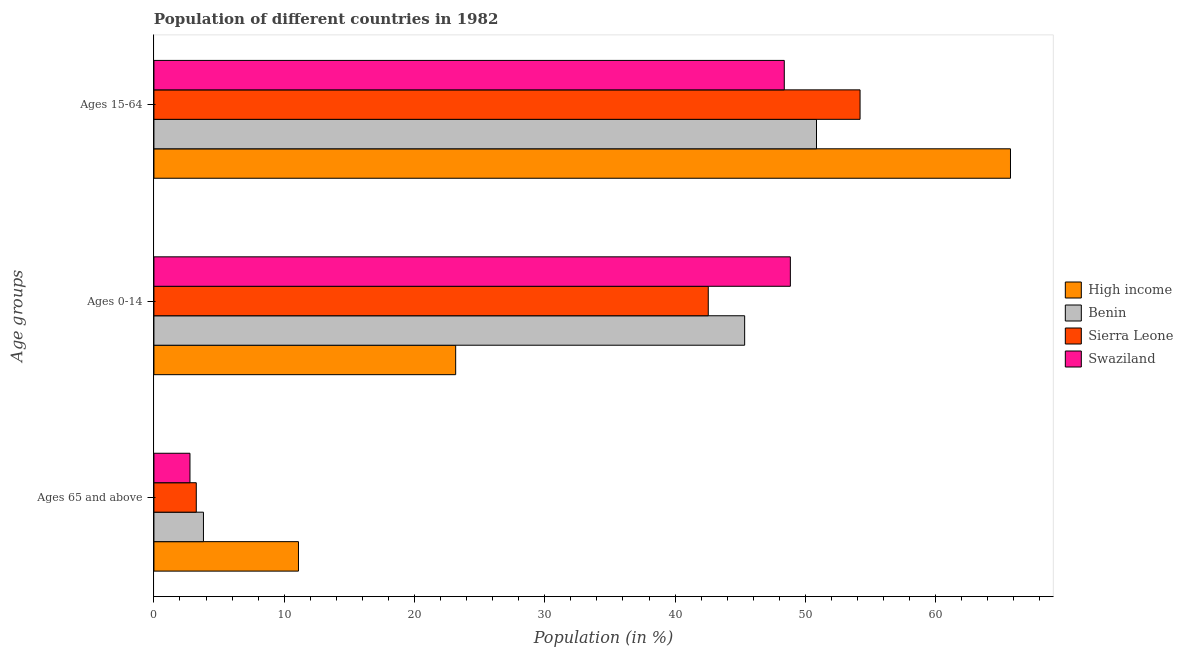How many different coloured bars are there?
Make the answer very short. 4. How many groups of bars are there?
Your answer should be compact. 3. What is the label of the 3rd group of bars from the top?
Your response must be concise. Ages 65 and above. What is the percentage of population within the age-group of 65 and above in Sierra Leone?
Provide a succinct answer. 3.25. Across all countries, what is the maximum percentage of population within the age-group 15-64?
Your answer should be compact. 65.75. Across all countries, what is the minimum percentage of population within the age-group 15-64?
Provide a short and direct response. 48.38. In which country was the percentage of population within the age-group 15-64 minimum?
Keep it short and to the point. Swaziland. What is the total percentage of population within the age-group 15-64 in the graph?
Provide a succinct answer. 219.19. What is the difference between the percentage of population within the age-group 0-14 in Benin and that in High income?
Make the answer very short. 22.18. What is the difference between the percentage of population within the age-group 15-64 in Sierra Leone and the percentage of population within the age-group 0-14 in High income?
Offer a terse response. 31.04. What is the average percentage of population within the age-group 0-14 per country?
Make the answer very short. 39.98. What is the difference between the percentage of population within the age-group of 65 and above and percentage of population within the age-group 15-64 in Swaziland?
Offer a very short reply. -45.62. In how many countries, is the percentage of population within the age-group of 65 and above greater than 62 %?
Provide a short and direct response. 0. What is the ratio of the percentage of population within the age-group 15-64 in Swaziland to that in Benin?
Keep it short and to the point. 0.95. Is the percentage of population within the age-group 0-14 in High income less than that in Sierra Leone?
Provide a succinct answer. Yes. Is the difference between the percentage of population within the age-group 15-64 in Swaziland and High income greater than the difference between the percentage of population within the age-group of 65 and above in Swaziland and High income?
Provide a succinct answer. No. What is the difference between the highest and the second highest percentage of population within the age-group 0-14?
Keep it short and to the point. 3.51. What is the difference between the highest and the lowest percentage of population within the age-group of 65 and above?
Ensure brevity in your answer.  8.33. Is the sum of the percentage of population within the age-group of 65 and above in Swaziland and Benin greater than the maximum percentage of population within the age-group 0-14 across all countries?
Your response must be concise. No. What does the 3rd bar from the bottom in Ages 15-64 represents?
Your answer should be compact. Sierra Leone. How many bars are there?
Provide a short and direct response. 12. Are all the bars in the graph horizontal?
Your response must be concise. Yes. What is the difference between two consecutive major ticks on the X-axis?
Your answer should be very brief. 10. Are the values on the major ticks of X-axis written in scientific E-notation?
Offer a terse response. No. Where does the legend appear in the graph?
Ensure brevity in your answer.  Center right. How many legend labels are there?
Offer a very short reply. 4. What is the title of the graph?
Provide a succinct answer. Population of different countries in 1982. What is the label or title of the X-axis?
Ensure brevity in your answer.  Population (in %). What is the label or title of the Y-axis?
Offer a very short reply. Age groups. What is the Population (in %) of High income in Ages 65 and above?
Your answer should be very brief. 11.09. What is the Population (in %) in Benin in Ages 65 and above?
Make the answer very short. 3.8. What is the Population (in %) of Sierra Leone in Ages 65 and above?
Give a very brief answer. 3.25. What is the Population (in %) of Swaziland in Ages 65 and above?
Offer a very short reply. 2.77. What is the Population (in %) in High income in Ages 0-14?
Offer a terse response. 23.16. What is the Population (in %) of Benin in Ages 0-14?
Provide a succinct answer. 45.34. What is the Population (in %) in Sierra Leone in Ages 0-14?
Make the answer very short. 42.55. What is the Population (in %) in Swaziland in Ages 0-14?
Ensure brevity in your answer.  48.85. What is the Population (in %) in High income in Ages 15-64?
Your answer should be very brief. 65.75. What is the Population (in %) of Benin in Ages 15-64?
Make the answer very short. 50.86. What is the Population (in %) in Sierra Leone in Ages 15-64?
Your response must be concise. 54.2. What is the Population (in %) of Swaziland in Ages 15-64?
Offer a very short reply. 48.38. Across all Age groups, what is the maximum Population (in %) of High income?
Keep it short and to the point. 65.75. Across all Age groups, what is the maximum Population (in %) of Benin?
Keep it short and to the point. 50.86. Across all Age groups, what is the maximum Population (in %) of Sierra Leone?
Offer a very short reply. 54.2. Across all Age groups, what is the maximum Population (in %) of Swaziland?
Your response must be concise. 48.85. Across all Age groups, what is the minimum Population (in %) of High income?
Keep it short and to the point. 11.09. Across all Age groups, what is the minimum Population (in %) of Benin?
Make the answer very short. 3.8. Across all Age groups, what is the minimum Population (in %) in Sierra Leone?
Provide a short and direct response. 3.25. Across all Age groups, what is the minimum Population (in %) of Swaziland?
Your answer should be very brief. 2.77. What is the total Population (in %) of Benin in the graph?
Make the answer very short. 100. What is the difference between the Population (in %) of High income in Ages 65 and above and that in Ages 0-14?
Make the answer very short. -12.07. What is the difference between the Population (in %) in Benin in Ages 65 and above and that in Ages 0-14?
Offer a terse response. -41.54. What is the difference between the Population (in %) in Sierra Leone in Ages 65 and above and that in Ages 0-14?
Ensure brevity in your answer.  -39.3. What is the difference between the Population (in %) in Swaziland in Ages 65 and above and that in Ages 0-14?
Your answer should be very brief. -46.08. What is the difference between the Population (in %) of High income in Ages 65 and above and that in Ages 15-64?
Your response must be concise. -54.65. What is the difference between the Population (in %) of Benin in Ages 65 and above and that in Ages 15-64?
Your answer should be very brief. -47.06. What is the difference between the Population (in %) in Sierra Leone in Ages 65 and above and that in Ages 15-64?
Provide a short and direct response. -50.95. What is the difference between the Population (in %) in Swaziland in Ages 65 and above and that in Ages 15-64?
Offer a very short reply. -45.62. What is the difference between the Population (in %) in High income in Ages 0-14 and that in Ages 15-64?
Keep it short and to the point. -42.59. What is the difference between the Population (in %) in Benin in Ages 0-14 and that in Ages 15-64?
Offer a terse response. -5.51. What is the difference between the Population (in %) of Sierra Leone in Ages 0-14 and that in Ages 15-64?
Your response must be concise. -11.65. What is the difference between the Population (in %) in Swaziland in Ages 0-14 and that in Ages 15-64?
Offer a terse response. 0.47. What is the difference between the Population (in %) of High income in Ages 65 and above and the Population (in %) of Benin in Ages 0-14?
Offer a very short reply. -34.25. What is the difference between the Population (in %) of High income in Ages 65 and above and the Population (in %) of Sierra Leone in Ages 0-14?
Offer a terse response. -31.45. What is the difference between the Population (in %) in High income in Ages 65 and above and the Population (in %) in Swaziland in Ages 0-14?
Make the answer very short. -37.76. What is the difference between the Population (in %) of Benin in Ages 65 and above and the Population (in %) of Sierra Leone in Ages 0-14?
Your answer should be compact. -38.75. What is the difference between the Population (in %) in Benin in Ages 65 and above and the Population (in %) in Swaziland in Ages 0-14?
Offer a terse response. -45.05. What is the difference between the Population (in %) of Sierra Leone in Ages 65 and above and the Population (in %) of Swaziland in Ages 0-14?
Make the answer very short. -45.6. What is the difference between the Population (in %) in High income in Ages 65 and above and the Population (in %) in Benin in Ages 15-64?
Provide a short and direct response. -39.76. What is the difference between the Population (in %) in High income in Ages 65 and above and the Population (in %) in Sierra Leone in Ages 15-64?
Your answer should be compact. -43.11. What is the difference between the Population (in %) in High income in Ages 65 and above and the Population (in %) in Swaziland in Ages 15-64?
Your answer should be very brief. -37.29. What is the difference between the Population (in %) in Benin in Ages 65 and above and the Population (in %) in Sierra Leone in Ages 15-64?
Your answer should be compact. -50.4. What is the difference between the Population (in %) of Benin in Ages 65 and above and the Population (in %) of Swaziland in Ages 15-64?
Your response must be concise. -44.58. What is the difference between the Population (in %) in Sierra Leone in Ages 65 and above and the Population (in %) in Swaziland in Ages 15-64?
Your answer should be very brief. -45.13. What is the difference between the Population (in %) in High income in Ages 0-14 and the Population (in %) in Benin in Ages 15-64?
Your response must be concise. -27.7. What is the difference between the Population (in %) in High income in Ages 0-14 and the Population (in %) in Sierra Leone in Ages 15-64?
Offer a terse response. -31.04. What is the difference between the Population (in %) of High income in Ages 0-14 and the Population (in %) of Swaziland in Ages 15-64?
Provide a short and direct response. -25.22. What is the difference between the Population (in %) of Benin in Ages 0-14 and the Population (in %) of Sierra Leone in Ages 15-64?
Make the answer very short. -8.86. What is the difference between the Population (in %) of Benin in Ages 0-14 and the Population (in %) of Swaziland in Ages 15-64?
Provide a succinct answer. -3.04. What is the difference between the Population (in %) of Sierra Leone in Ages 0-14 and the Population (in %) of Swaziland in Ages 15-64?
Provide a short and direct response. -5.83. What is the average Population (in %) of High income per Age groups?
Make the answer very short. 33.33. What is the average Population (in %) in Benin per Age groups?
Provide a short and direct response. 33.33. What is the average Population (in %) in Sierra Leone per Age groups?
Keep it short and to the point. 33.33. What is the average Population (in %) of Swaziland per Age groups?
Ensure brevity in your answer.  33.33. What is the difference between the Population (in %) in High income and Population (in %) in Benin in Ages 65 and above?
Your answer should be compact. 7.29. What is the difference between the Population (in %) of High income and Population (in %) of Sierra Leone in Ages 65 and above?
Provide a succinct answer. 7.84. What is the difference between the Population (in %) of High income and Population (in %) of Swaziland in Ages 65 and above?
Provide a short and direct response. 8.33. What is the difference between the Population (in %) in Benin and Population (in %) in Sierra Leone in Ages 65 and above?
Ensure brevity in your answer.  0.55. What is the difference between the Population (in %) of Benin and Population (in %) of Swaziland in Ages 65 and above?
Offer a terse response. 1.03. What is the difference between the Population (in %) in Sierra Leone and Population (in %) in Swaziland in Ages 65 and above?
Provide a short and direct response. 0.48. What is the difference between the Population (in %) in High income and Population (in %) in Benin in Ages 0-14?
Your response must be concise. -22.18. What is the difference between the Population (in %) of High income and Population (in %) of Sierra Leone in Ages 0-14?
Your response must be concise. -19.39. What is the difference between the Population (in %) of High income and Population (in %) of Swaziland in Ages 0-14?
Your response must be concise. -25.69. What is the difference between the Population (in %) of Benin and Population (in %) of Sierra Leone in Ages 0-14?
Offer a very short reply. 2.79. What is the difference between the Population (in %) in Benin and Population (in %) in Swaziland in Ages 0-14?
Give a very brief answer. -3.51. What is the difference between the Population (in %) of Sierra Leone and Population (in %) of Swaziland in Ages 0-14?
Make the answer very short. -6.3. What is the difference between the Population (in %) in High income and Population (in %) in Benin in Ages 15-64?
Provide a short and direct response. 14.89. What is the difference between the Population (in %) in High income and Population (in %) in Sierra Leone in Ages 15-64?
Offer a very short reply. 11.55. What is the difference between the Population (in %) of High income and Population (in %) of Swaziland in Ages 15-64?
Your response must be concise. 17.36. What is the difference between the Population (in %) of Benin and Population (in %) of Sierra Leone in Ages 15-64?
Make the answer very short. -3.34. What is the difference between the Population (in %) in Benin and Population (in %) in Swaziland in Ages 15-64?
Provide a succinct answer. 2.47. What is the difference between the Population (in %) of Sierra Leone and Population (in %) of Swaziland in Ages 15-64?
Ensure brevity in your answer.  5.82. What is the ratio of the Population (in %) of High income in Ages 65 and above to that in Ages 0-14?
Your answer should be very brief. 0.48. What is the ratio of the Population (in %) of Benin in Ages 65 and above to that in Ages 0-14?
Provide a succinct answer. 0.08. What is the ratio of the Population (in %) in Sierra Leone in Ages 65 and above to that in Ages 0-14?
Ensure brevity in your answer.  0.08. What is the ratio of the Population (in %) of Swaziland in Ages 65 and above to that in Ages 0-14?
Give a very brief answer. 0.06. What is the ratio of the Population (in %) of High income in Ages 65 and above to that in Ages 15-64?
Make the answer very short. 0.17. What is the ratio of the Population (in %) in Benin in Ages 65 and above to that in Ages 15-64?
Keep it short and to the point. 0.07. What is the ratio of the Population (in %) in Sierra Leone in Ages 65 and above to that in Ages 15-64?
Offer a terse response. 0.06. What is the ratio of the Population (in %) in Swaziland in Ages 65 and above to that in Ages 15-64?
Give a very brief answer. 0.06. What is the ratio of the Population (in %) of High income in Ages 0-14 to that in Ages 15-64?
Provide a succinct answer. 0.35. What is the ratio of the Population (in %) of Benin in Ages 0-14 to that in Ages 15-64?
Ensure brevity in your answer.  0.89. What is the ratio of the Population (in %) in Sierra Leone in Ages 0-14 to that in Ages 15-64?
Your answer should be compact. 0.79. What is the ratio of the Population (in %) in Swaziland in Ages 0-14 to that in Ages 15-64?
Provide a short and direct response. 1.01. What is the difference between the highest and the second highest Population (in %) in High income?
Offer a terse response. 42.59. What is the difference between the highest and the second highest Population (in %) of Benin?
Offer a terse response. 5.51. What is the difference between the highest and the second highest Population (in %) of Sierra Leone?
Provide a short and direct response. 11.65. What is the difference between the highest and the second highest Population (in %) in Swaziland?
Your response must be concise. 0.47. What is the difference between the highest and the lowest Population (in %) in High income?
Your answer should be compact. 54.65. What is the difference between the highest and the lowest Population (in %) in Benin?
Give a very brief answer. 47.06. What is the difference between the highest and the lowest Population (in %) of Sierra Leone?
Your answer should be very brief. 50.95. What is the difference between the highest and the lowest Population (in %) of Swaziland?
Give a very brief answer. 46.08. 